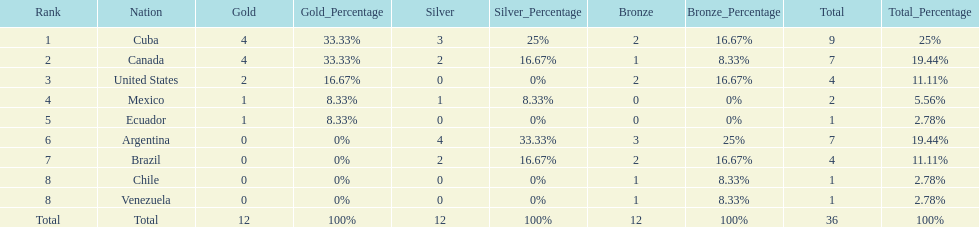How many total medals were there all together? 36. 